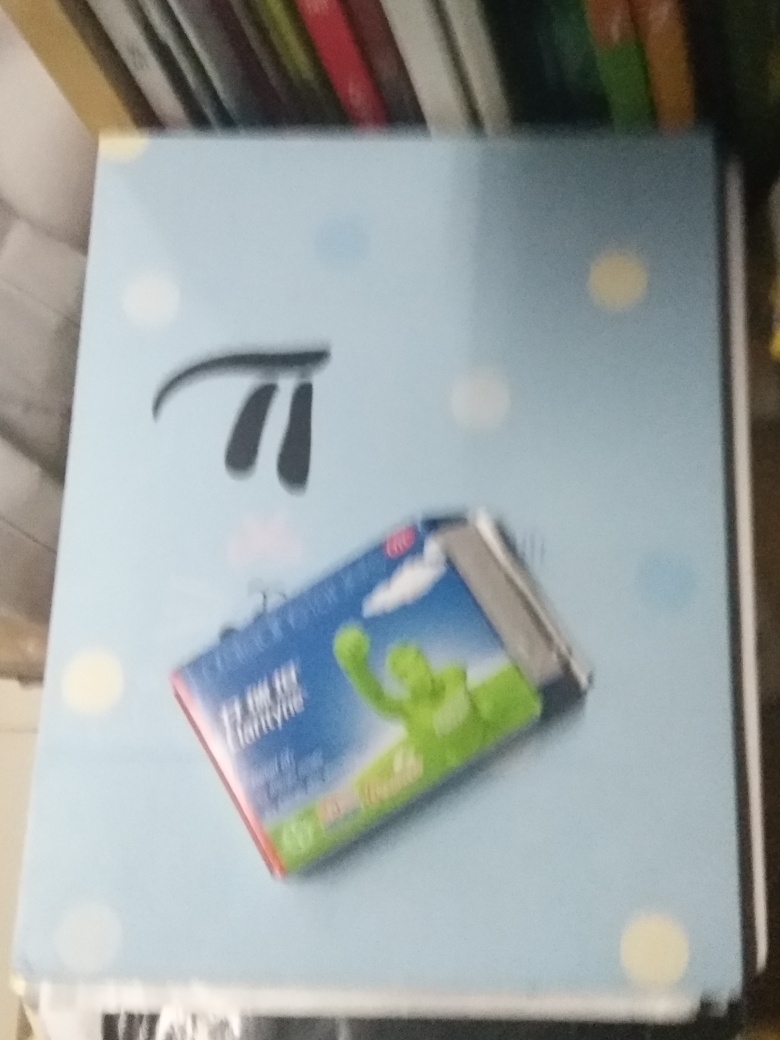What is the overall quality of the image? Upon reviewing the image, it is clear that the quality is notably lower than standard due to the blurriness and lack of focus. This can make it difficult to discern fine details. However, the subject—a toothpaste box—can still be made out, which would place the quality slightly above very poor. An improvement in the sharpness and clarity would greatly enhance the image's quality. 